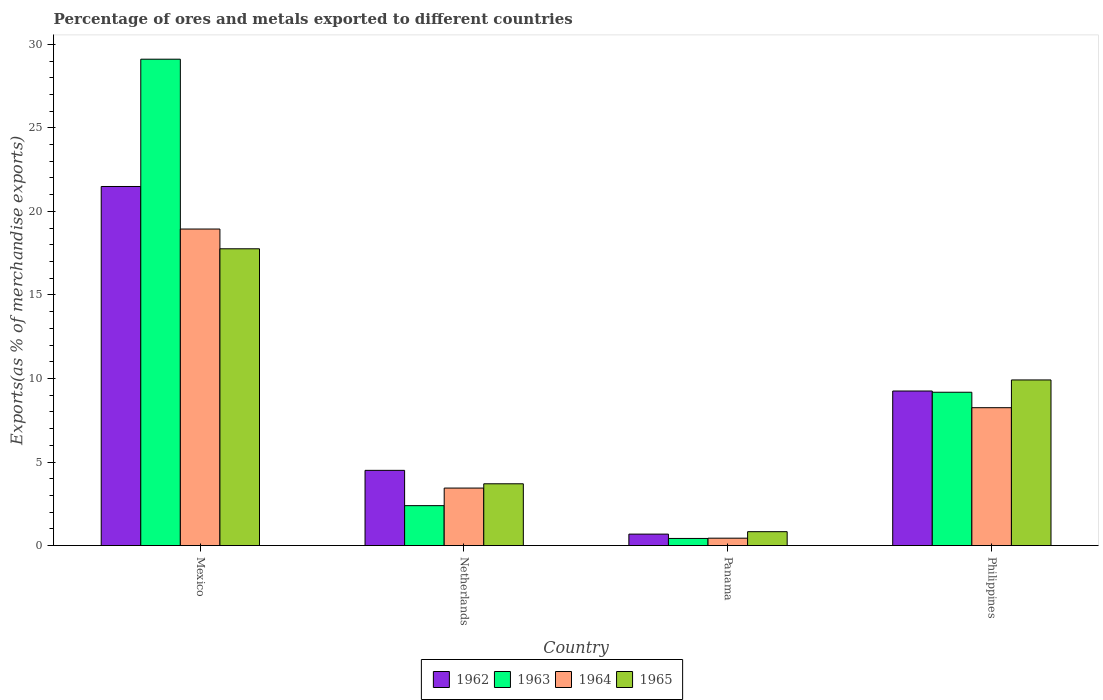Are the number of bars on each tick of the X-axis equal?
Your response must be concise. Yes. How many bars are there on the 4th tick from the left?
Offer a very short reply. 4. How many bars are there on the 2nd tick from the right?
Your answer should be compact. 4. What is the percentage of exports to different countries in 1964 in Netherlands?
Your answer should be compact. 3.44. Across all countries, what is the maximum percentage of exports to different countries in 1962?
Provide a succinct answer. 21.49. Across all countries, what is the minimum percentage of exports to different countries in 1962?
Provide a short and direct response. 0.69. In which country was the percentage of exports to different countries in 1964 maximum?
Ensure brevity in your answer.  Mexico. In which country was the percentage of exports to different countries in 1963 minimum?
Provide a short and direct response. Panama. What is the total percentage of exports to different countries in 1964 in the graph?
Your answer should be compact. 31.08. What is the difference between the percentage of exports to different countries in 1963 in Panama and that in Philippines?
Your response must be concise. -8.75. What is the difference between the percentage of exports to different countries in 1965 in Panama and the percentage of exports to different countries in 1963 in Mexico?
Your answer should be very brief. -28.28. What is the average percentage of exports to different countries in 1964 per country?
Your answer should be very brief. 7.77. What is the difference between the percentage of exports to different countries of/in 1965 and percentage of exports to different countries of/in 1962 in Philippines?
Your answer should be compact. 0.66. In how many countries, is the percentage of exports to different countries in 1965 greater than 29 %?
Offer a very short reply. 0. What is the ratio of the percentage of exports to different countries in 1964 in Mexico to that in Philippines?
Give a very brief answer. 2.3. Is the difference between the percentage of exports to different countries in 1965 in Netherlands and Philippines greater than the difference between the percentage of exports to different countries in 1962 in Netherlands and Philippines?
Make the answer very short. No. What is the difference between the highest and the second highest percentage of exports to different countries in 1965?
Your answer should be compact. 14.06. What is the difference between the highest and the lowest percentage of exports to different countries in 1963?
Ensure brevity in your answer.  28.68. Is the sum of the percentage of exports to different countries in 1962 in Mexico and Philippines greater than the maximum percentage of exports to different countries in 1965 across all countries?
Your answer should be very brief. Yes. What does the 3rd bar from the left in Netherlands represents?
Your response must be concise. 1964. What does the 2nd bar from the right in Netherlands represents?
Provide a short and direct response. 1964. Where does the legend appear in the graph?
Keep it short and to the point. Bottom center. How many legend labels are there?
Your answer should be very brief. 4. How are the legend labels stacked?
Your response must be concise. Horizontal. What is the title of the graph?
Your answer should be compact. Percentage of ores and metals exported to different countries. Does "1996" appear as one of the legend labels in the graph?
Provide a short and direct response. No. What is the label or title of the X-axis?
Make the answer very short. Country. What is the label or title of the Y-axis?
Make the answer very short. Exports(as % of merchandise exports). What is the Exports(as % of merchandise exports) in 1962 in Mexico?
Ensure brevity in your answer.  21.49. What is the Exports(as % of merchandise exports) of 1963 in Mexico?
Make the answer very short. 29.11. What is the Exports(as % of merchandise exports) of 1964 in Mexico?
Ensure brevity in your answer.  18.94. What is the Exports(as % of merchandise exports) of 1965 in Mexico?
Offer a very short reply. 17.76. What is the Exports(as % of merchandise exports) of 1962 in Netherlands?
Provide a succinct answer. 4.5. What is the Exports(as % of merchandise exports) in 1963 in Netherlands?
Make the answer very short. 2.39. What is the Exports(as % of merchandise exports) of 1964 in Netherlands?
Give a very brief answer. 3.44. What is the Exports(as % of merchandise exports) of 1965 in Netherlands?
Offer a very short reply. 3.7. What is the Exports(as % of merchandise exports) in 1962 in Panama?
Offer a terse response. 0.69. What is the Exports(as % of merchandise exports) in 1963 in Panama?
Your answer should be compact. 0.43. What is the Exports(as % of merchandise exports) of 1964 in Panama?
Ensure brevity in your answer.  0.44. What is the Exports(as % of merchandise exports) of 1965 in Panama?
Provide a succinct answer. 0.83. What is the Exports(as % of merchandise exports) in 1962 in Philippines?
Give a very brief answer. 9.25. What is the Exports(as % of merchandise exports) of 1963 in Philippines?
Offer a very short reply. 9.18. What is the Exports(as % of merchandise exports) in 1964 in Philippines?
Offer a terse response. 8.25. What is the Exports(as % of merchandise exports) of 1965 in Philippines?
Make the answer very short. 9.91. Across all countries, what is the maximum Exports(as % of merchandise exports) of 1962?
Give a very brief answer. 21.49. Across all countries, what is the maximum Exports(as % of merchandise exports) of 1963?
Provide a succinct answer. 29.11. Across all countries, what is the maximum Exports(as % of merchandise exports) of 1964?
Offer a very short reply. 18.94. Across all countries, what is the maximum Exports(as % of merchandise exports) of 1965?
Your answer should be very brief. 17.76. Across all countries, what is the minimum Exports(as % of merchandise exports) in 1962?
Offer a terse response. 0.69. Across all countries, what is the minimum Exports(as % of merchandise exports) in 1963?
Give a very brief answer. 0.43. Across all countries, what is the minimum Exports(as % of merchandise exports) of 1964?
Your answer should be very brief. 0.44. Across all countries, what is the minimum Exports(as % of merchandise exports) of 1965?
Provide a succinct answer. 0.83. What is the total Exports(as % of merchandise exports) in 1962 in the graph?
Provide a short and direct response. 35.93. What is the total Exports(as % of merchandise exports) in 1963 in the graph?
Your answer should be very brief. 41.1. What is the total Exports(as % of merchandise exports) in 1964 in the graph?
Offer a very short reply. 31.08. What is the total Exports(as % of merchandise exports) of 1965 in the graph?
Provide a succinct answer. 32.2. What is the difference between the Exports(as % of merchandise exports) in 1962 in Mexico and that in Netherlands?
Provide a short and direct response. 16.99. What is the difference between the Exports(as % of merchandise exports) of 1963 in Mexico and that in Netherlands?
Make the answer very short. 26.72. What is the difference between the Exports(as % of merchandise exports) in 1964 in Mexico and that in Netherlands?
Your response must be concise. 15.5. What is the difference between the Exports(as % of merchandise exports) in 1965 in Mexico and that in Netherlands?
Offer a terse response. 14.06. What is the difference between the Exports(as % of merchandise exports) of 1962 in Mexico and that in Panama?
Make the answer very short. 20.81. What is the difference between the Exports(as % of merchandise exports) in 1963 in Mexico and that in Panama?
Offer a terse response. 28.68. What is the difference between the Exports(as % of merchandise exports) of 1964 in Mexico and that in Panama?
Offer a terse response. 18.5. What is the difference between the Exports(as % of merchandise exports) in 1965 in Mexico and that in Panama?
Your answer should be very brief. 16.93. What is the difference between the Exports(as % of merchandise exports) in 1962 in Mexico and that in Philippines?
Provide a succinct answer. 12.24. What is the difference between the Exports(as % of merchandise exports) of 1963 in Mexico and that in Philippines?
Offer a terse response. 19.93. What is the difference between the Exports(as % of merchandise exports) in 1964 in Mexico and that in Philippines?
Your answer should be compact. 10.69. What is the difference between the Exports(as % of merchandise exports) in 1965 in Mexico and that in Philippines?
Make the answer very short. 7.85. What is the difference between the Exports(as % of merchandise exports) in 1962 in Netherlands and that in Panama?
Offer a very short reply. 3.82. What is the difference between the Exports(as % of merchandise exports) in 1963 in Netherlands and that in Panama?
Your answer should be very brief. 1.96. What is the difference between the Exports(as % of merchandise exports) of 1964 in Netherlands and that in Panama?
Give a very brief answer. 3. What is the difference between the Exports(as % of merchandise exports) of 1965 in Netherlands and that in Panama?
Provide a short and direct response. 2.87. What is the difference between the Exports(as % of merchandise exports) in 1962 in Netherlands and that in Philippines?
Offer a terse response. -4.75. What is the difference between the Exports(as % of merchandise exports) in 1963 in Netherlands and that in Philippines?
Your response must be concise. -6.79. What is the difference between the Exports(as % of merchandise exports) in 1964 in Netherlands and that in Philippines?
Offer a very short reply. -4.81. What is the difference between the Exports(as % of merchandise exports) of 1965 in Netherlands and that in Philippines?
Your answer should be very brief. -6.21. What is the difference between the Exports(as % of merchandise exports) in 1962 in Panama and that in Philippines?
Ensure brevity in your answer.  -8.56. What is the difference between the Exports(as % of merchandise exports) in 1963 in Panama and that in Philippines?
Ensure brevity in your answer.  -8.75. What is the difference between the Exports(as % of merchandise exports) of 1964 in Panama and that in Philippines?
Provide a short and direct response. -7.81. What is the difference between the Exports(as % of merchandise exports) in 1965 in Panama and that in Philippines?
Keep it short and to the point. -9.08. What is the difference between the Exports(as % of merchandise exports) in 1962 in Mexico and the Exports(as % of merchandise exports) in 1963 in Netherlands?
Give a very brief answer. 19.1. What is the difference between the Exports(as % of merchandise exports) of 1962 in Mexico and the Exports(as % of merchandise exports) of 1964 in Netherlands?
Your answer should be compact. 18.05. What is the difference between the Exports(as % of merchandise exports) in 1962 in Mexico and the Exports(as % of merchandise exports) in 1965 in Netherlands?
Make the answer very short. 17.79. What is the difference between the Exports(as % of merchandise exports) of 1963 in Mexico and the Exports(as % of merchandise exports) of 1964 in Netherlands?
Provide a short and direct response. 25.67. What is the difference between the Exports(as % of merchandise exports) of 1963 in Mexico and the Exports(as % of merchandise exports) of 1965 in Netherlands?
Your answer should be compact. 25.41. What is the difference between the Exports(as % of merchandise exports) in 1964 in Mexico and the Exports(as % of merchandise exports) in 1965 in Netherlands?
Give a very brief answer. 15.25. What is the difference between the Exports(as % of merchandise exports) of 1962 in Mexico and the Exports(as % of merchandise exports) of 1963 in Panama?
Provide a succinct answer. 21.06. What is the difference between the Exports(as % of merchandise exports) of 1962 in Mexico and the Exports(as % of merchandise exports) of 1964 in Panama?
Your answer should be very brief. 21.05. What is the difference between the Exports(as % of merchandise exports) in 1962 in Mexico and the Exports(as % of merchandise exports) in 1965 in Panama?
Provide a succinct answer. 20.66. What is the difference between the Exports(as % of merchandise exports) of 1963 in Mexico and the Exports(as % of merchandise exports) of 1964 in Panama?
Offer a very short reply. 28.67. What is the difference between the Exports(as % of merchandise exports) of 1963 in Mexico and the Exports(as % of merchandise exports) of 1965 in Panama?
Keep it short and to the point. 28.28. What is the difference between the Exports(as % of merchandise exports) in 1964 in Mexico and the Exports(as % of merchandise exports) in 1965 in Panama?
Your response must be concise. 18.11. What is the difference between the Exports(as % of merchandise exports) in 1962 in Mexico and the Exports(as % of merchandise exports) in 1963 in Philippines?
Your answer should be very brief. 12.31. What is the difference between the Exports(as % of merchandise exports) in 1962 in Mexico and the Exports(as % of merchandise exports) in 1964 in Philippines?
Make the answer very short. 13.24. What is the difference between the Exports(as % of merchandise exports) in 1962 in Mexico and the Exports(as % of merchandise exports) in 1965 in Philippines?
Provide a succinct answer. 11.58. What is the difference between the Exports(as % of merchandise exports) in 1963 in Mexico and the Exports(as % of merchandise exports) in 1964 in Philippines?
Offer a very short reply. 20.86. What is the difference between the Exports(as % of merchandise exports) of 1963 in Mexico and the Exports(as % of merchandise exports) of 1965 in Philippines?
Provide a short and direct response. 19.2. What is the difference between the Exports(as % of merchandise exports) in 1964 in Mexico and the Exports(as % of merchandise exports) in 1965 in Philippines?
Make the answer very short. 9.03. What is the difference between the Exports(as % of merchandise exports) in 1962 in Netherlands and the Exports(as % of merchandise exports) in 1963 in Panama?
Give a very brief answer. 4.07. What is the difference between the Exports(as % of merchandise exports) of 1962 in Netherlands and the Exports(as % of merchandise exports) of 1964 in Panama?
Ensure brevity in your answer.  4.06. What is the difference between the Exports(as % of merchandise exports) in 1962 in Netherlands and the Exports(as % of merchandise exports) in 1965 in Panama?
Your answer should be very brief. 3.67. What is the difference between the Exports(as % of merchandise exports) of 1963 in Netherlands and the Exports(as % of merchandise exports) of 1964 in Panama?
Your response must be concise. 1.95. What is the difference between the Exports(as % of merchandise exports) in 1963 in Netherlands and the Exports(as % of merchandise exports) in 1965 in Panama?
Give a very brief answer. 1.56. What is the difference between the Exports(as % of merchandise exports) of 1964 in Netherlands and the Exports(as % of merchandise exports) of 1965 in Panama?
Provide a succinct answer. 2.61. What is the difference between the Exports(as % of merchandise exports) in 1962 in Netherlands and the Exports(as % of merchandise exports) in 1963 in Philippines?
Your answer should be compact. -4.67. What is the difference between the Exports(as % of merchandise exports) in 1962 in Netherlands and the Exports(as % of merchandise exports) in 1964 in Philippines?
Your response must be concise. -3.75. What is the difference between the Exports(as % of merchandise exports) of 1962 in Netherlands and the Exports(as % of merchandise exports) of 1965 in Philippines?
Provide a succinct answer. -5.41. What is the difference between the Exports(as % of merchandise exports) in 1963 in Netherlands and the Exports(as % of merchandise exports) in 1964 in Philippines?
Make the answer very short. -5.86. What is the difference between the Exports(as % of merchandise exports) of 1963 in Netherlands and the Exports(as % of merchandise exports) of 1965 in Philippines?
Offer a very short reply. -7.52. What is the difference between the Exports(as % of merchandise exports) in 1964 in Netherlands and the Exports(as % of merchandise exports) in 1965 in Philippines?
Ensure brevity in your answer.  -6.47. What is the difference between the Exports(as % of merchandise exports) in 1962 in Panama and the Exports(as % of merchandise exports) in 1963 in Philippines?
Offer a very short reply. -8.49. What is the difference between the Exports(as % of merchandise exports) in 1962 in Panama and the Exports(as % of merchandise exports) in 1964 in Philippines?
Ensure brevity in your answer.  -7.57. What is the difference between the Exports(as % of merchandise exports) in 1962 in Panama and the Exports(as % of merchandise exports) in 1965 in Philippines?
Your answer should be compact. -9.23. What is the difference between the Exports(as % of merchandise exports) in 1963 in Panama and the Exports(as % of merchandise exports) in 1964 in Philippines?
Your answer should be very brief. -7.83. What is the difference between the Exports(as % of merchandise exports) in 1963 in Panama and the Exports(as % of merchandise exports) in 1965 in Philippines?
Offer a terse response. -9.49. What is the difference between the Exports(as % of merchandise exports) in 1964 in Panama and the Exports(as % of merchandise exports) in 1965 in Philippines?
Your response must be concise. -9.47. What is the average Exports(as % of merchandise exports) of 1962 per country?
Keep it short and to the point. 8.98. What is the average Exports(as % of merchandise exports) of 1963 per country?
Ensure brevity in your answer.  10.28. What is the average Exports(as % of merchandise exports) in 1964 per country?
Make the answer very short. 7.77. What is the average Exports(as % of merchandise exports) in 1965 per country?
Provide a short and direct response. 8.05. What is the difference between the Exports(as % of merchandise exports) of 1962 and Exports(as % of merchandise exports) of 1963 in Mexico?
Your response must be concise. -7.62. What is the difference between the Exports(as % of merchandise exports) of 1962 and Exports(as % of merchandise exports) of 1964 in Mexico?
Your response must be concise. 2.55. What is the difference between the Exports(as % of merchandise exports) of 1962 and Exports(as % of merchandise exports) of 1965 in Mexico?
Provide a short and direct response. 3.73. What is the difference between the Exports(as % of merchandise exports) of 1963 and Exports(as % of merchandise exports) of 1964 in Mexico?
Offer a terse response. 10.16. What is the difference between the Exports(as % of merchandise exports) in 1963 and Exports(as % of merchandise exports) in 1965 in Mexico?
Offer a terse response. 11.35. What is the difference between the Exports(as % of merchandise exports) in 1964 and Exports(as % of merchandise exports) in 1965 in Mexico?
Your answer should be very brief. 1.18. What is the difference between the Exports(as % of merchandise exports) in 1962 and Exports(as % of merchandise exports) in 1963 in Netherlands?
Provide a succinct answer. 2.11. What is the difference between the Exports(as % of merchandise exports) of 1962 and Exports(as % of merchandise exports) of 1964 in Netherlands?
Offer a very short reply. 1.06. What is the difference between the Exports(as % of merchandise exports) in 1962 and Exports(as % of merchandise exports) in 1965 in Netherlands?
Your response must be concise. 0.8. What is the difference between the Exports(as % of merchandise exports) in 1963 and Exports(as % of merchandise exports) in 1964 in Netherlands?
Make the answer very short. -1.05. What is the difference between the Exports(as % of merchandise exports) of 1963 and Exports(as % of merchandise exports) of 1965 in Netherlands?
Keep it short and to the point. -1.31. What is the difference between the Exports(as % of merchandise exports) of 1964 and Exports(as % of merchandise exports) of 1965 in Netherlands?
Ensure brevity in your answer.  -0.26. What is the difference between the Exports(as % of merchandise exports) of 1962 and Exports(as % of merchandise exports) of 1963 in Panama?
Offer a very short reply. 0.26. What is the difference between the Exports(as % of merchandise exports) in 1962 and Exports(as % of merchandise exports) in 1964 in Panama?
Your response must be concise. 0.24. What is the difference between the Exports(as % of merchandise exports) of 1962 and Exports(as % of merchandise exports) of 1965 in Panama?
Make the answer very short. -0.15. What is the difference between the Exports(as % of merchandise exports) of 1963 and Exports(as % of merchandise exports) of 1964 in Panama?
Your answer should be compact. -0.02. What is the difference between the Exports(as % of merchandise exports) in 1963 and Exports(as % of merchandise exports) in 1965 in Panama?
Your answer should be compact. -0.4. What is the difference between the Exports(as % of merchandise exports) in 1964 and Exports(as % of merchandise exports) in 1965 in Panama?
Keep it short and to the point. -0.39. What is the difference between the Exports(as % of merchandise exports) in 1962 and Exports(as % of merchandise exports) in 1963 in Philippines?
Your answer should be compact. 0.07. What is the difference between the Exports(as % of merchandise exports) of 1962 and Exports(as % of merchandise exports) of 1964 in Philippines?
Your answer should be compact. 1. What is the difference between the Exports(as % of merchandise exports) in 1962 and Exports(as % of merchandise exports) in 1965 in Philippines?
Ensure brevity in your answer.  -0.66. What is the difference between the Exports(as % of merchandise exports) of 1963 and Exports(as % of merchandise exports) of 1964 in Philippines?
Your answer should be compact. 0.92. What is the difference between the Exports(as % of merchandise exports) of 1963 and Exports(as % of merchandise exports) of 1965 in Philippines?
Provide a short and direct response. -0.74. What is the difference between the Exports(as % of merchandise exports) of 1964 and Exports(as % of merchandise exports) of 1965 in Philippines?
Offer a terse response. -1.66. What is the ratio of the Exports(as % of merchandise exports) in 1962 in Mexico to that in Netherlands?
Keep it short and to the point. 4.77. What is the ratio of the Exports(as % of merchandise exports) of 1963 in Mexico to that in Netherlands?
Your answer should be very brief. 12.18. What is the ratio of the Exports(as % of merchandise exports) of 1964 in Mexico to that in Netherlands?
Provide a short and direct response. 5.51. What is the ratio of the Exports(as % of merchandise exports) in 1965 in Mexico to that in Netherlands?
Provide a succinct answer. 4.8. What is the ratio of the Exports(as % of merchandise exports) in 1962 in Mexico to that in Panama?
Provide a short and direct response. 31.37. What is the ratio of the Exports(as % of merchandise exports) of 1963 in Mexico to that in Panama?
Provide a succinct answer. 68.27. What is the ratio of the Exports(as % of merchandise exports) of 1964 in Mexico to that in Panama?
Make the answer very short. 42.84. What is the ratio of the Exports(as % of merchandise exports) of 1965 in Mexico to that in Panama?
Provide a short and direct response. 21.38. What is the ratio of the Exports(as % of merchandise exports) in 1962 in Mexico to that in Philippines?
Provide a short and direct response. 2.32. What is the ratio of the Exports(as % of merchandise exports) of 1963 in Mexico to that in Philippines?
Offer a very short reply. 3.17. What is the ratio of the Exports(as % of merchandise exports) in 1964 in Mexico to that in Philippines?
Offer a very short reply. 2.3. What is the ratio of the Exports(as % of merchandise exports) in 1965 in Mexico to that in Philippines?
Make the answer very short. 1.79. What is the ratio of the Exports(as % of merchandise exports) in 1962 in Netherlands to that in Panama?
Keep it short and to the point. 6.57. What is the ratio of the Exports(as % of merchandise exports) of 1963 in Netherlands to that in Panama?
Your answer should be very brief. 5.6. What is the ratio of the Exports(as % of merchandise exports) of 1964 in Netherlands to that in Panama?
Your answer should be compact. 7.78. What is the ratio of the Exports(as % of merchandise exports) of 1965 in Netherlands to that in Panama?
Provide a succinct answer. 4.45. What is the ratio of the Exports(as % of merchandise exports) of 1962 in Netherlands to that in Philippines?
Ensure brevity in your answer.  0.49. What is the ratio of the Exports(as % of merchandise exports) in 1963 in Netherlands to that in Philippines?
Keep it short and to the point. 0.26. What is the ratio of the Exports(as % of merchandise exports) of 1964 in Netherlands to that in Philippines?
Keep it short and to the point. 0.42. What is the ratio of the Exports(as % of merchandise exports) in 1965 in Netherlands to that in Philippines?
Provide a short and direct response. 0.37. What is the ratio of the Exports(as % of merchandise exports) in 1962 in Panama to that in Philippines?
Your answer should be compact. 0.07. What is the ratio of the Exports(as % of merchandise exports) in 1963 in Panama to that in Philippines?
Ensure brevity in your answer.  0.05. What is the ratio of the Exports(as % of merchandise exports) in 1964 in Panama to that in Philippines?
Ensure brevity in your answer.  0.05. What is the ratio of the Exports(as % of merchandise exports) in 1965 in Panama to that in Philippines?
Offer a terse response. 0.08. What is the difference between the highest and the second highest Exports(as % of merchandise exports) in 1962?
Offer a very short reply. 12.24. What is the difference between the highest and the second highest Exports(as % of merchandise exports) in 1963?
Offer a very short reply. 19.93. What is the difference between the highest and the second highest Exports(as % of merchandise exports) of 1964?
Ensure brevity in your answer.  10.69. What is the difference between the highest and the second highest Exports(as % of merchandise exports) in 1965?
Your response must be concise. 7.85. What is the difference between the highest and the lowest Exports(as % of merchandise exports) of 1962?
Ensure brevity in your answer.  20.81. What is the difference between the highest and the lowest Exports(as % of merchandise exports) of 1963?
Give a very brief answer. 28.68. What is the difference between the highest and the lowest Exports(as % of merchandise exports) in 1964?
Your answer should be compact. 18.5. What is the difference between the highest and the lowest Exports(as % of merchandise exports) of 1965?
Provide a succinct answer. 16.93. 